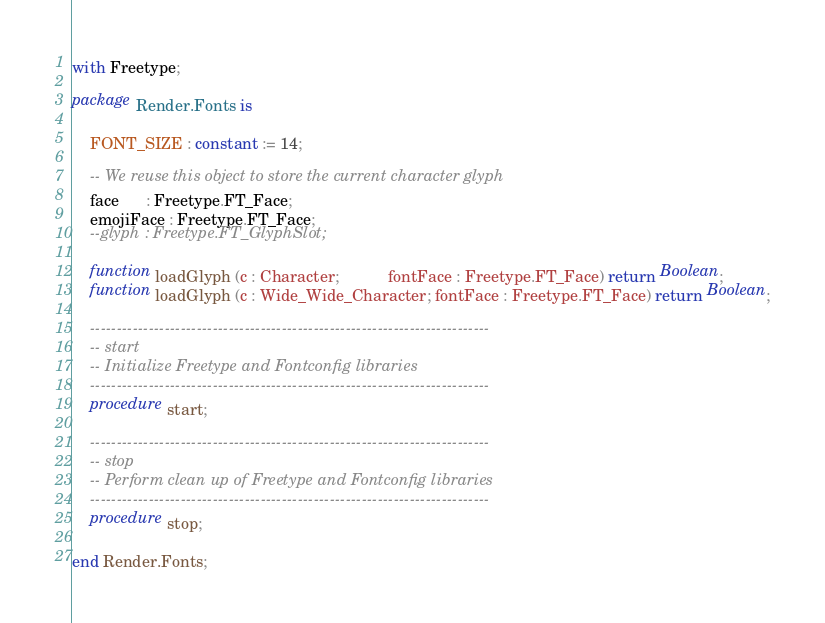Convert code to text. <code><loc_0><loc_0><loc_500><loc_500><_Ada_>with Freetype;

package Render.Fonts is

    FONT_SIZE : constant := 14;

    -- We reuse this object to store the current character glyph
    face      : Freetype.FT_Face;
    emojiFace : Freetype.FT_Face;
    --glyph : Freetype.FT_GlyphSlot;

    function loadGlyph (c : Character;           fontFace : Freetype.FT_Face) return Boolean;
    function loadGlyph (c : Wide_Wide_Character; fontFace : Freetype.FT_Face) return Boolean;

    ---------------------------------------------------------------------------
    -- start
    -- Initialize Freetype and Fontconfig libraries
    ---------------------------------------------------------------------------
    procedure start;

    ---------------------------------------------------------------------------
    -- stop
    -- Perform clean up of Freetype and Fontconfig libraries
    ---------------------------------------------------------------------------
    procedure stop;

end Render.Fonts;</code> 